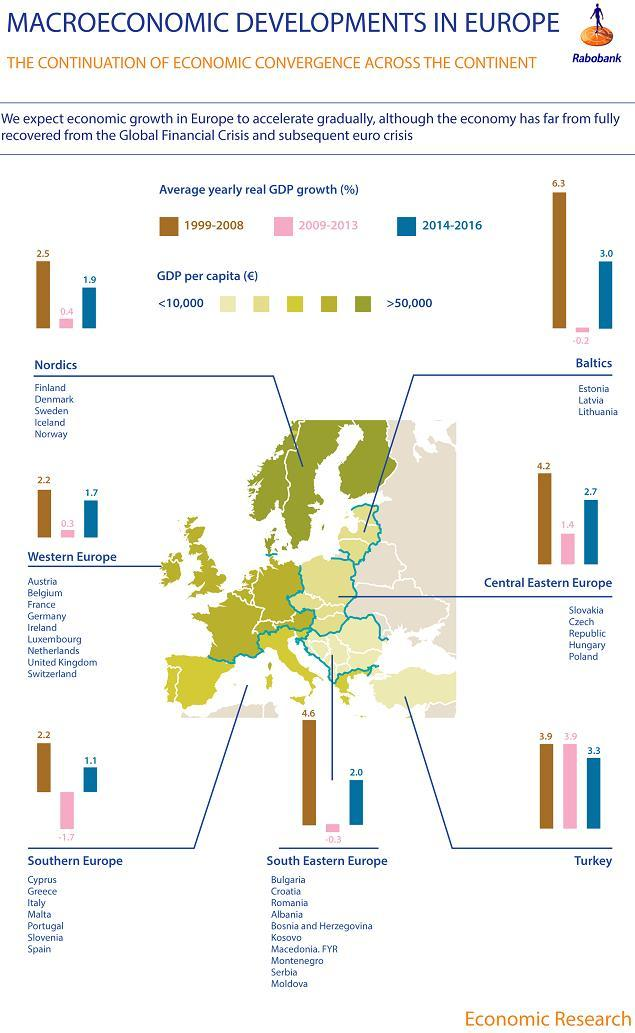What was the highest negative GDP growth registered in 2009-2013?
Answer the question with a short phrase. -1.7% Which regions had a negative GDP growth in the period 2009-2013? Baltics, Southern Europe, South Eastern Europe Which region had the highest average yearly real GDP growth in the period 2009-2013? Turkey Which region had the highest average yearly GDP growth during the year 2014-2016? Turkey Which region had the highest average yearly GDP growth during the year 1999-2008? Baltics 